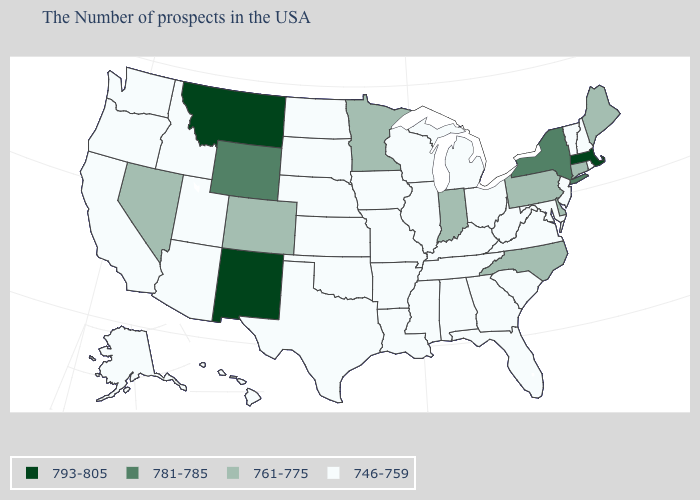What is the value of Alaska?
Keep it brief. 746-759. What is the value of Wisconsin?
Short answer required. 746-759. Which states hav the highest value in the Northeast?
Give a very brief answer. Massachusetts. What is the highest value in the USA?
Write a very short answer. 793-805. What is the value of Delaware?
Short answer required. 761-775. Name the states that have a value in the range 761-775?
Concise answer only. Maine, Connecticut, Delaware, Pennsylvania, North Carolina, Indiana, Minnesota, Colorado, Nevada. What is the value of New Mexico?
Concise answer only. 793-805. How many symbols are there in the legend?
Give a very brief answer. 4. What is the value of Vermont?
Keep it brief. 746-759. What is the value of South Dakota?
Quick response, please. 746-759. Name the states that have a value in the range 746-759?
Write a very short answer. Rhode Island, New Hampshire, Vermont, New Jersey, Maryland, Virginia, South Carolina, West Virginia, Ohio, Florida, Georgia, Michigan, Kentucky, Alabama, Tennessee, Wisconsin, Illinois, Mississippi, Louisiana, Missouri, Arkansas, Iowa, Kansas, Nebraska, Oklahoma, Texas, South Dakota, North Dakota, Utah, Arizona, Idaho, California, Washington, Oregon, Alaska, Hawaii. How many symbols are there in the legend?
Give a very brief answer. 4. Does Maine have the lowest value in the Northeast?
Give a very brief answer. No. Name the states that have a value in the range 781-785?
Short answer required. New York, Wyoming. Name the states that have a value in the range 781-785?
Be succinct. New York, Wyoming. 